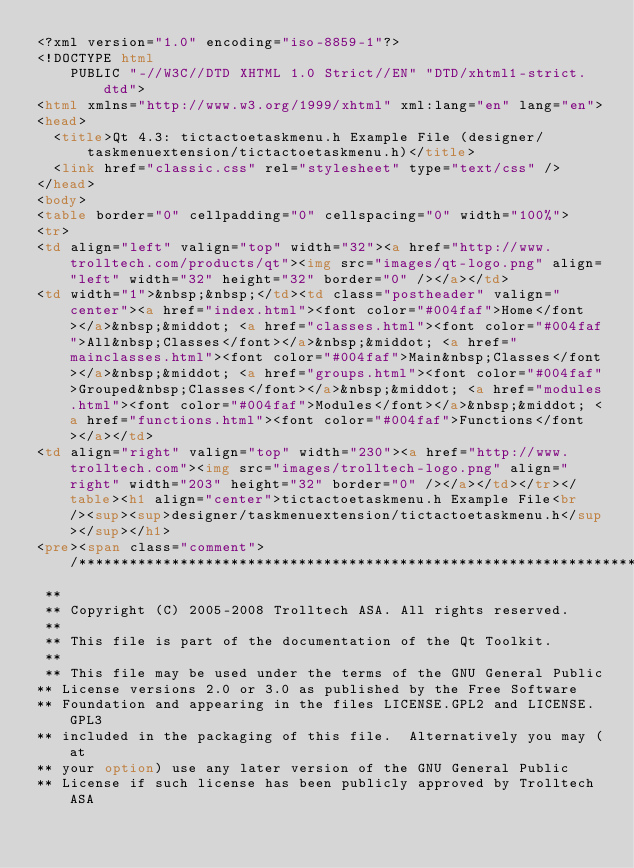<code> <loc_0><loc_0><loc_500><loc_500><_HTML_><?xml version="1.0" encoding="iso-8859-1"?>
<!DOCTYPE html
    PUBLIC "-//W3C//DTD XHTML 1.0 Strict//EN" "DTD/xhtml1-strict.dtd">
<html xmlns="http://www.w3.org/1999/xhtml" xml:lang="en" lang="en">
<head>
  <title>Qt 4.3: tictactoetaskmenu.h Example File (designer/taskmenuextension/tictactoetaskmenu.h)</title>
  <link href="classic.css" rel="stylesheet" type="text/css" />
</head>
<body>
<table border="0" cellpadding="0" cellspacing="0" width="100%">
<tr>
<td align="left" valign="top" width="32"><a href="http://www.trolltech.com/products/qt"><img src="images/qt-logo.png" align="left" width="32" height="32" border="0" /></a></td>
<td width="1">&nbsp;&nbsp;</td><td class="postheader" valign="center"><a href="index.html"><font color="#004faf">Home</font></a>&nbsp;&middot; <a href="classes.html"><font color="#004faf">All&nbsp;Classes</font></a>&nbsp;&middot; <a href="mainclasses.html"><font color="#004faf">Main&nbsp;Classes</font></a>&nbsp;&middot; <a href="groups.html"><font color="#004faf">Grouped&nbsp;Classes</font></a>&nbsp;&middot; <a href="modules.html"><font color="#004faf">Modules</font></a>&nbsp;&middot; <a href="functions.html"><font color="#004faf">Functions</font></a></td>
<td align="right" valign="top" width="230"><a href="http://www.trolltech.com"><img src="images/trolltech-logo.png" align="right" width="203" height="32" border="0" /></a></td></tr></table><h1 align="center">tictactoetaskmenu.h Example File<br /><sup><sup>designer/taskmenuextension/tictactoetaskmenu.h</sup></sup></h1>
<pre><span class="comment"> /****************************************************************************
 **
 ** Copyright (C) 2005-2008 Trolltech ASA. All rights reserved.
 **
 ** This file is part of the documentation of the Qt Toolkit.
 **
 ** This file may be used under the terms of the GNU General Public
** License versions 2.0 or 3.0 as published by the Free Software
** Foundation and appearing in the files LICENSE.GPL2 and LICENSE.GPL3
** included in the packaging of this file.  Alternatively you may (at
** your option) use any later version of the GNU General Public
** License if such license has been publicly approved by Trolltech ASA</code> 